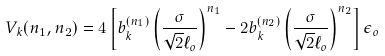Convert formula to latex. <formula><loc_0><loc_0><loc_500><loc_500>V _ { k } ( n _ { 1 } , n _ { 2 } ) = 4 \left [ b _ { k } ^ { ( n _ { 1 } ) } \left ( \frac { \sigma } { \sqrt { 2 } \ell _ { o } } \right ) ^ { n _ { 1 } } - 2 b _ { k } ^ { ( n _ { 2 } ) } \left ( \frac { \sigma } { \sqrt { 2 } \ell _ { o } } \right ) ^ { n _ { 2 } } \right ] \epsilon _ { o }</formula> 